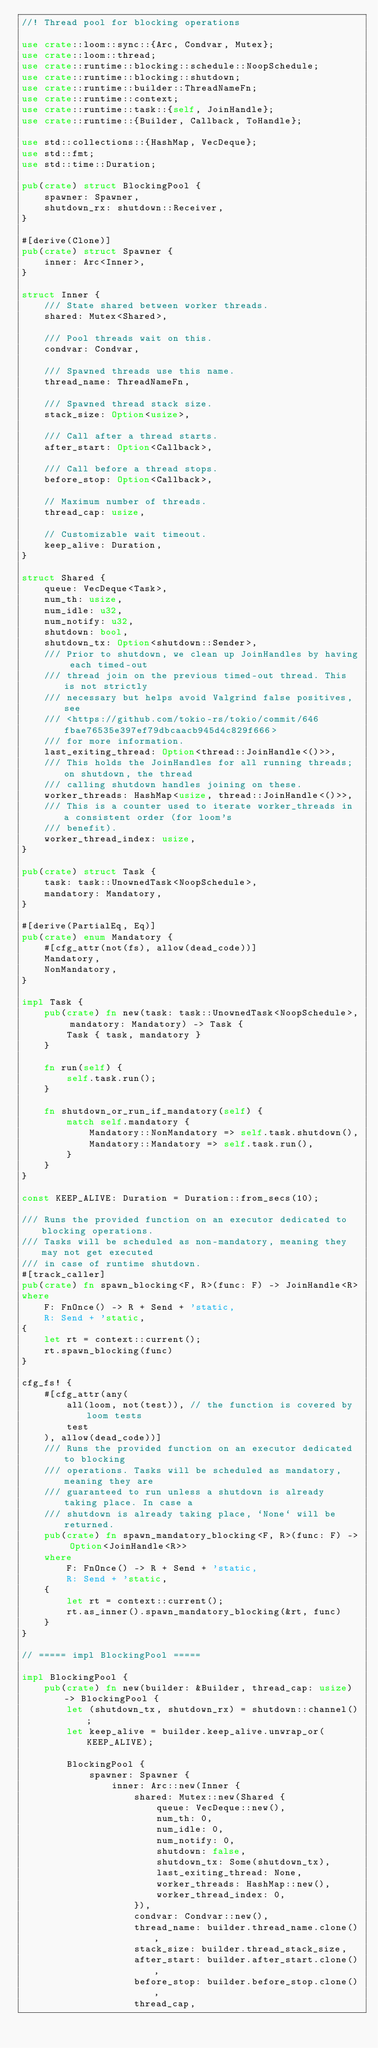<code> <loc_0><loc_0><loc_500><loc_500><_Rust_>//! Thread pool for blocking operations

use crate::loom::sync::{Arc, Condvar, Mutex};
use crate::loom::thread;
use crate::runtime::blocking::schedule::NoopSchedule;
use crate::runtime::blocking::shutdown;
use crate::runtime::builder::ThreadNameFn;
use crate::runtime::context;
use crate::runtime::task::{self, JoinHandle};
use crate::runtime::{Builder, Callback, ToHandle};

use std::collections::{HashMap, VecDeque};
use std::fmt;
use std::time::Duration;

pub(crate) struct BlockingPool {
    spawner: Spawner,
    shutdown_rx: shutdown::Receiver,
}

#[derive(Clone)]
pub(crate) struct Spawner {
    inner: Arc<Inner>,
}

struct Inner {
    /// State shared between worker threads.
    shared: Mutex<Shared>,

    /// Pool threads wait on this.
    condvar: Condvar,

    /// Spawned threads use this name.
    thread_name: ThreadNameFn,

    /// Spawned thread stack size.
    stack_size: Option<usize>,

    /// Call after a thread starts.
    after_start: Option<Callback>,

    /// Call before a thread stops.
    before_stop: Option<Callback>,

    // Maximum number of threads.
    thread_cap: usize,

    // Customizable wait timeout.
    keep_alive: Duration,
}

struct Shared {
    queue: VecDeque<Task>,
    num_th: usize,
    num_idle: u32,
    num_notify: u32,
    shutdown: bool,
    shutdown_tx: Option<shutdown::Sender>,
    /// Prior to shutdown, we clean up JoinHandles by having each timed-out
    /// thread join on the previous timed-out thread. This is not strictly
    /// necessary but helps avoid Valgrind false positives, see
    /// <https://github.com/tokio-rs/tokio/commit/646fbae76535e397ef79dbcaacb945d4c829f666>
    /// for more information.
    last_exiting_thread: Option<thread::JoinHandle<()>>,
    /// This holds the JoinHandles for all running threads; on shutdown, the thread
    /// calling shutdown handles joining on these.
    worker_threads: HashMap<usize, thread::JoinHandle<()>>,
    /// This is a counter used to iterate worker_threads in a consistent order (for loom's
    /// benefit).
    worker_thread_index: usize,
}

pub(crate) struct Task {
    task: task::UnownedTask<NoopSchedule>,
    mandatory: Mandatory,
}

#[derive(PartialEq, Eq)]
pub(crate) enum Mandatory {
    #[cfg_attr(not(fs), allow(dead_code))]
    Mandatory,
    NonMandatory,
}

impl Task {
    pub(crate) fn new(task: task::UnownedTask<NoopSchedule>, mandatory: Mandatory) -> Task {
        Task { task, mandatory }
    }

    fn run(self) {
        self.task.run();
    }

    fn shutdown_or_run_if_mandatory(self) {
        match self.mandatory {
            Mandatory::NonMandatory => self.task.shutdown(),
            Mandatory::Mandatory => self.task.run(),
        }
    }
}

const KEEP_ALIVE: Duration = Duration::from_secs(10);

/// Runs the provided function on an executor dedicated to blocking operations.
/// Tasks will be scheduled as non-mandatory, meaning they may not get executed
/// in case of runtime shutdown.
#[track_caller]
pub(crate) fn spawn_blocking<F, R>(func: F) -> JoinHandle<R>
where
    F: FnOnce() -> R + Send + 'static,
    R: Send + 'static,
{
    let rt = context::current();
    rt.spawn_blocking(func)
}

cfg_fs! {
    #[cfg_attr(any(
        all(loom, not(test)), // the function is covered by loom tests
        test
    ), allow(dead_code))]
    /// Runs the provided function on an executor dedicated to blocking
    /// operations. Tasks will be scheduled as mandatory, meaning they are
    /// guaranteed to run unless a shutdown is already taking place. In case a
    /// shutdown is already taking place, `None` will be returned.
    pub(crate) fn spawn_mandatory_blocking<F, R>(func: F) -> Option<JoinHandle<R>>
    where
        F: FnOnce() -> R + Send + 'static,
        R: Send + 'static,
    {
        let rt = context::current();
        rt.as_inner().spawn_mandatory_blocking(&rt, func)
    }
}

// ===== impl BlockingPool =====

impl BlockingPool {
    pub(crate) fn new(builder: &Builder, thread_cap: usize) -> BlockingPool {
        let (shutdown_tx, shutdown_rx) = shutdown::channel();
        let keep_alive = builder.keep_alive.unwrap_or(KEEP_ALIVE);

        BlockingPool {
            spawner: Spawner {
                inner: Arc::new(Inner {
                    shared: Mutex::new(Shared {
                        queue: VecDeque::new(),
                        num_th: 0,
                        num_idle: 0,
                        num_notify: 0,
                        shutdown: false,
                        shutdown_tx: Some(shutdown_tx),
                        last_exiting_thread: None,
                        worker_threads: HashMap::new(),
                        worker_thread_index: 0,
                    }),
                    condvar: Condvar::new(),
                    thread_name: builder.thread_name.clone(),
                    stack_size: builder.thread_stack_size,
                    after_start: builder.after_start.clone(),
                    before_stop: builder.before_stop.clone(),
                    thread_cap,</code> 